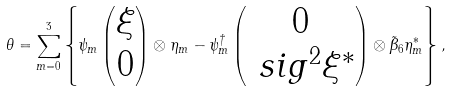Convert formula to latex. <formula><loc_0><loc_0><loc_500><loc_500>\theta = \sum _ { m = 0 } ^ { 3 } \left \{ \psi _ { m } \begin{pmatrix} \xi \\ 0 \end{pmatrix} \otimes \eta _ { m } - \psi _ { m } ^ { \dagger } \begin{pmatrix} 0 \\ \ s i g ^ { 2 } \xi ^ { \ast } \end{pmatrix} \otimes \tilde { \beta } _ { 6 } \eta _ { m } ^ { \ast } \right \} ,</formula> 